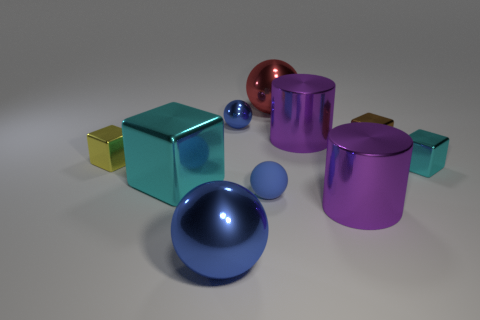Subtract all blue cylinders. How many blue spheres are left? 3 Subtract all spheres. How many objects are left? 6 Subtract all big brown shiny cylinders. Subtract all cylinders. How many objects are left? 8 Add 6 brown metallic blocks. How many brown metallic blocks are left? 7 Add 1 blue metallic cubes. How many blue metallic cubes exist? 1 Subtract 0 blue cubes. How many objects are left? 10 